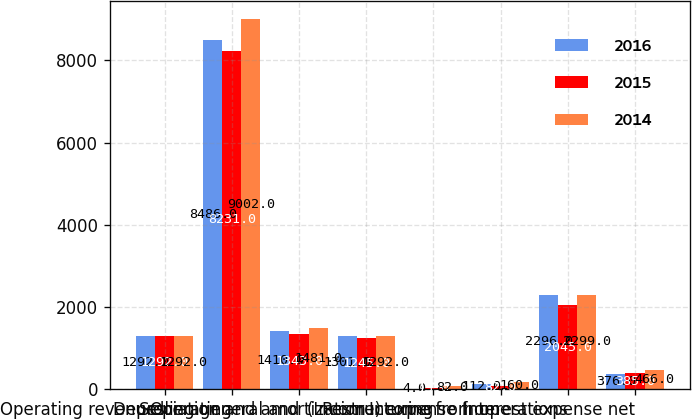<chart> <loc_0><loc_0><loc_500><loc_500><stacked_bar_chart><ecel><fcel>Operating revenues<fcel>Operating<fcel>Selling general and<fcel>Depreciation and amortization<fcel>Restructuring<fcel>(Income) expense from<fcel>Income from operations<fcel>Interest expense net<nl><fcel>2016<fcel>1292<fcel>8486<fcel>1410<fcel>1301<fcel>4<fcel>112<fcel>2296<fcel>376<nl><fcel>2015<fcel>1292<fcel>8231<fcel>1343<fcel>1245<fcel>15<fcel>82<fcel>2045<fcel>385<nl><fcel>2014<fcel>1292<fcel>9002<fcel>1481<fcel>1292<fcel>82<fcel>160<fcel>2299<fcel>466<nl></chart> 